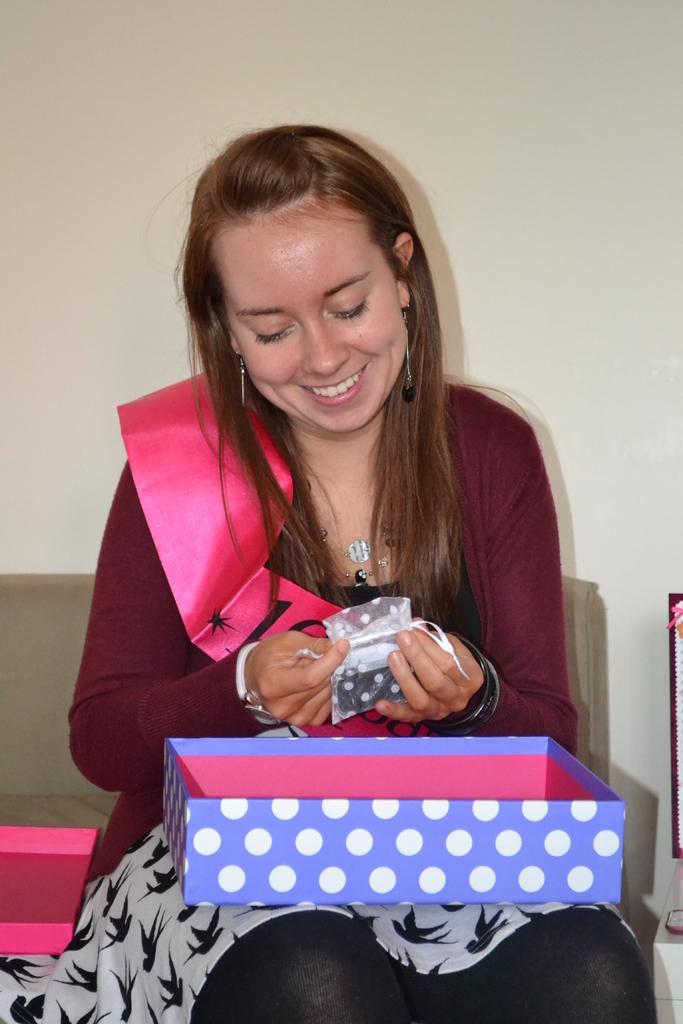Could you give a brief overview of what you see in this image? In this image we can see a woman sitting holding a cover and a cardboard box. On the backside we can see a couch and a wall. 